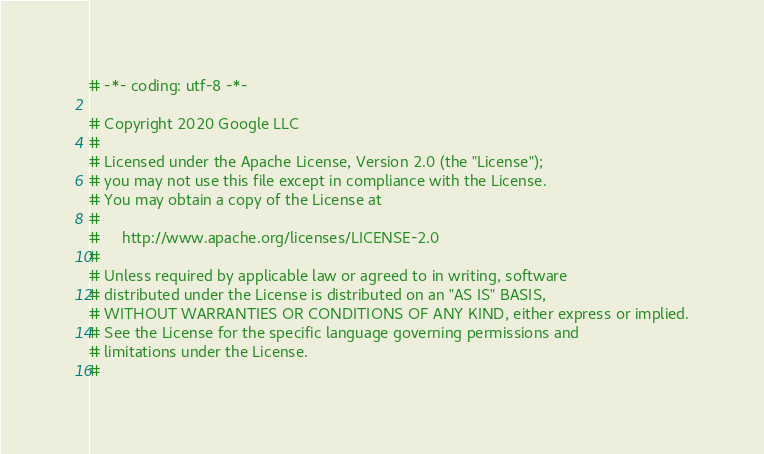Convert code to text. <code><loc_0><loc_0><loc_500><loc_500><_Python_># -*- coding: utf-8 -*-

# Copyright 2020 Google LLC
#
# Licensed under the Apache License, Version 2.0 (the "License");
# you may not use this file except in compliance with the License.
# You may obtain a copy of the License at
#
#     http://www.apache.org/licenses/LICENSE-2.0
#
# Unless required by applicable law or agreed to in writing, software
# distributed under the License is distributed on an "AS IS" BASIS,
# WITHOUT WARRANTIES OR CONDITIONS OF ANY KIND, either express or implied.
# See the License for the specific language governing permissions and
# limitations under the License.
#
</code> 